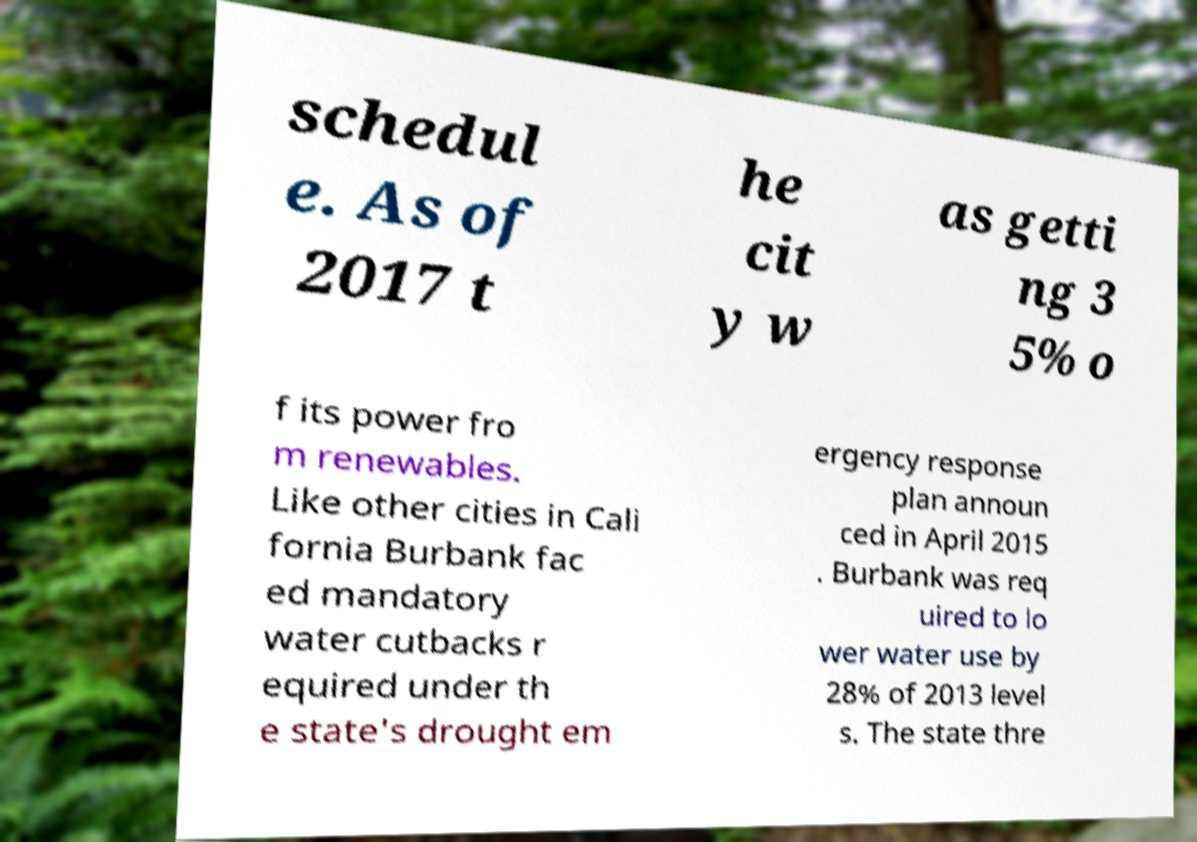Please read and relay the text visible in this image. What does it say? schedul e. As of 2017 t he cit y w as getti ng 3 5% o f its power fro m renewables. Like other cities in Cali fornia Burbank fac ed mandatory water cutbacks r equired under th e state's drought em ergency response plan announ ced in April 2015 . Burbank was req uired to lo wer water use by 28% of 2013 level s. The state thre 